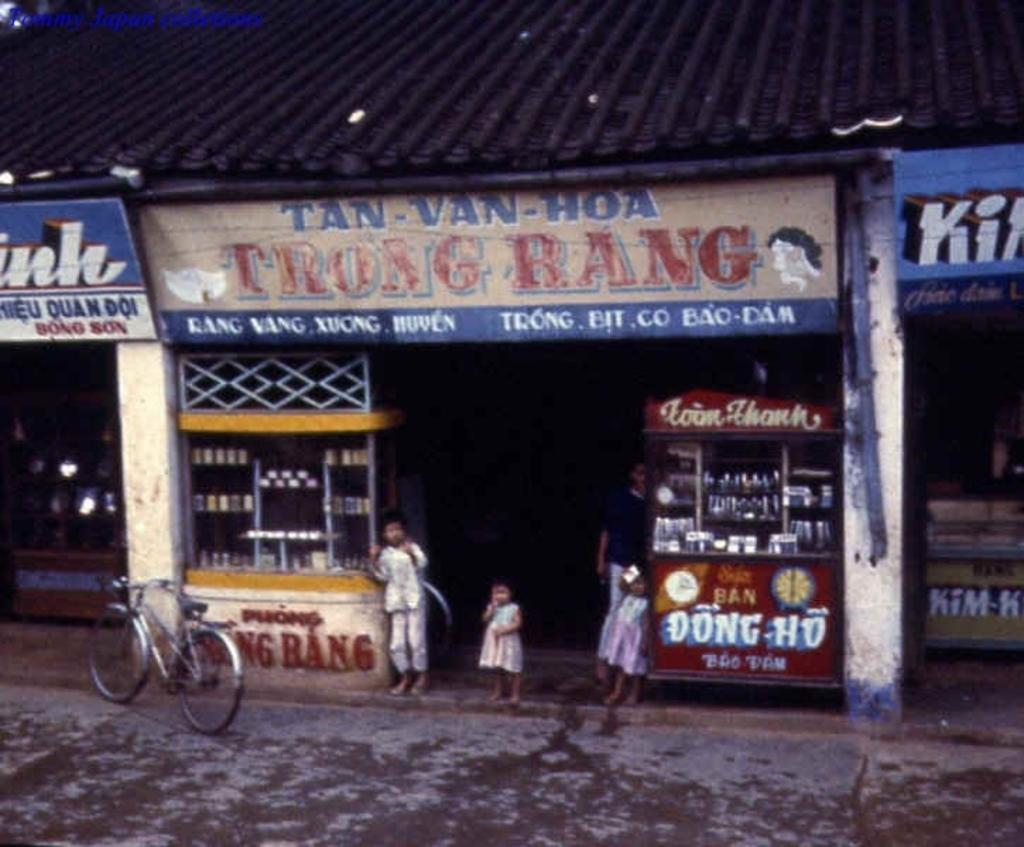What type of pathway is visible in the image? There is a road in the image. What type of establishments can be seen along the road? There are shops and stalls in the image. What mode of transportation is present in the image? There is a cycle in the image. Are there any signs or notices visible in the image? Yes, there are boards with text in the image. Can you see a boy blowing out candles on a cake in the image? There is no boy or cake present in the image. 